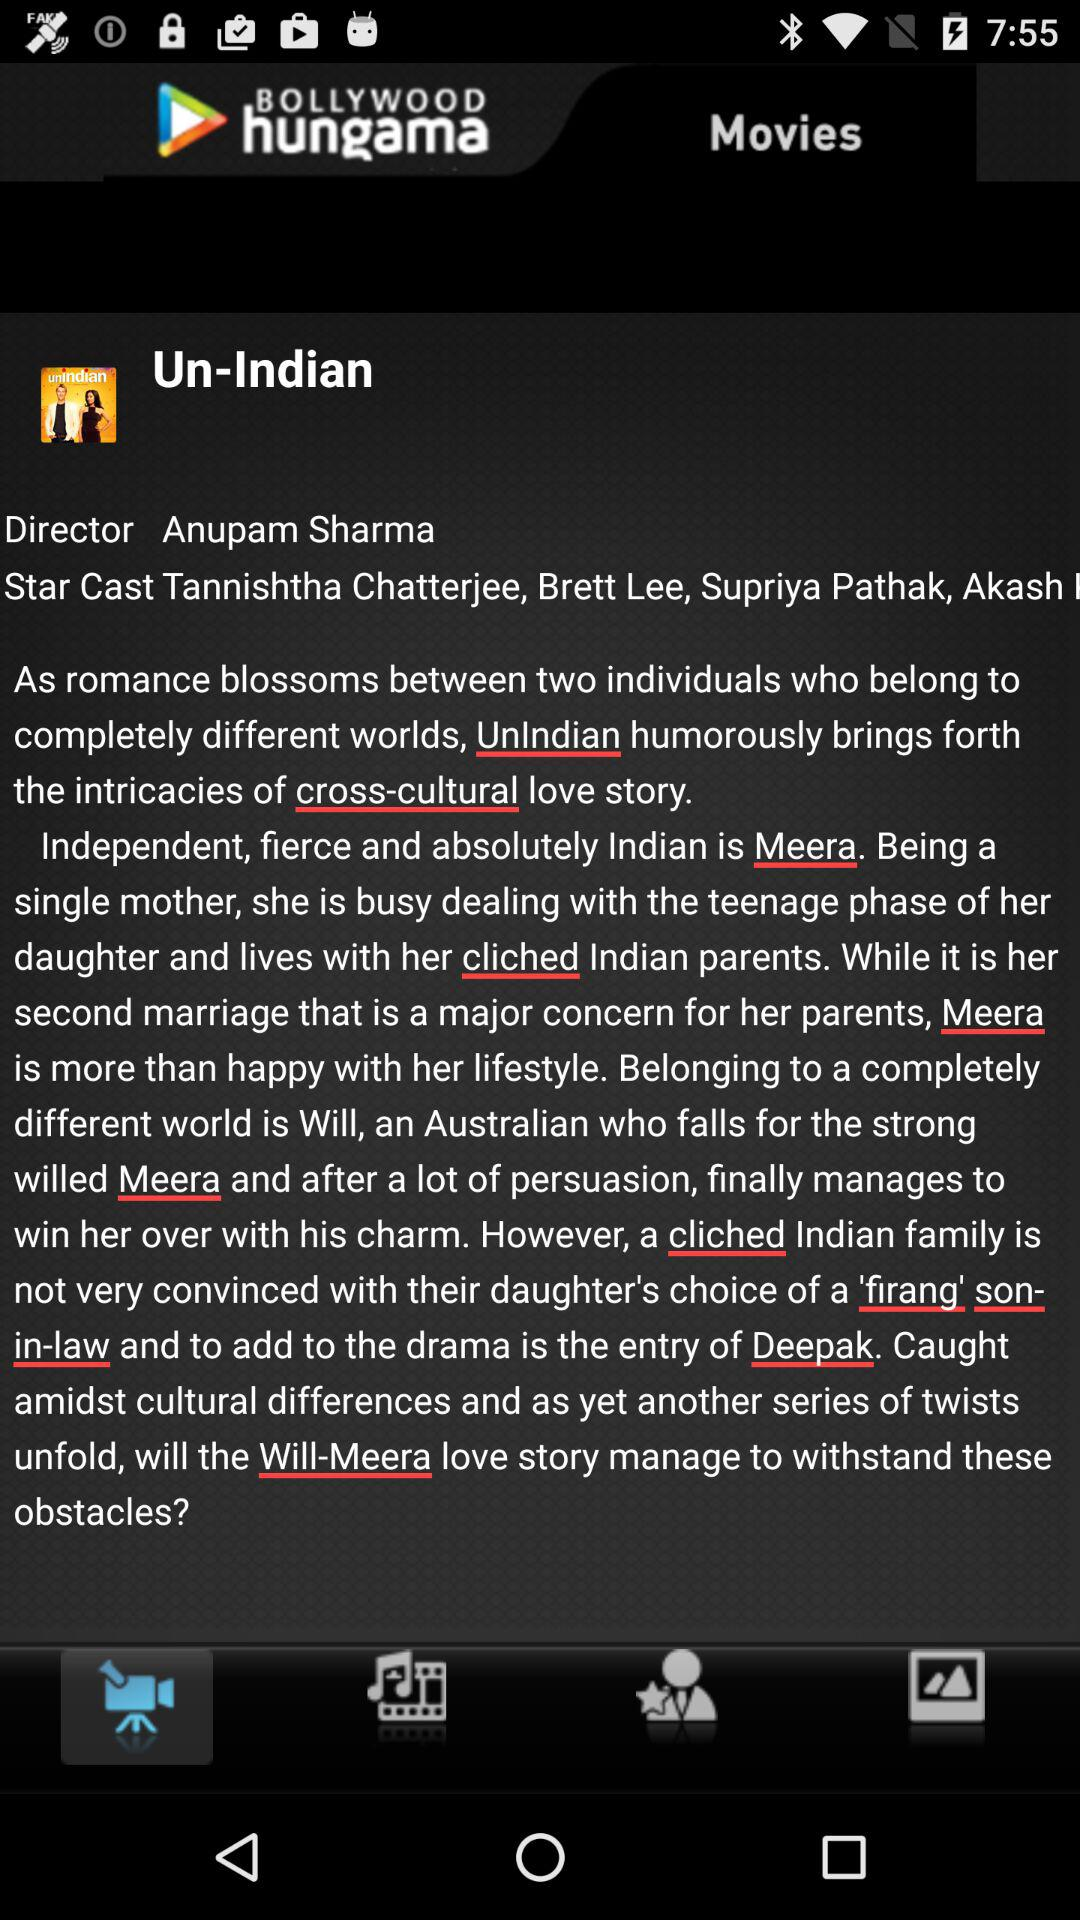What is the application name? The application name is "BOLLYWOOD hungama". 